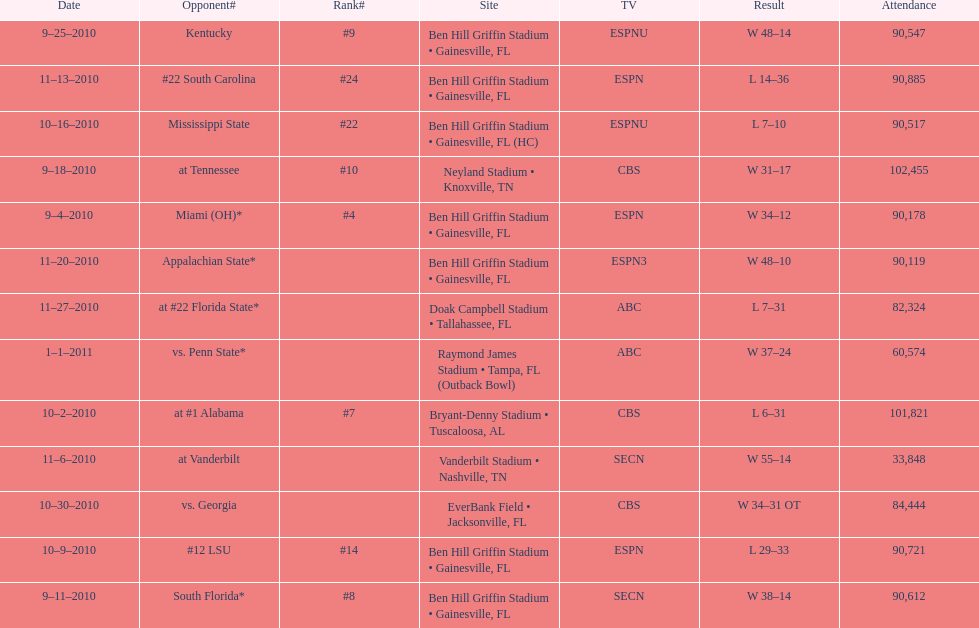How many consecutive weeks did the the gators win until the had their first lost in the 2010 season? 4. 